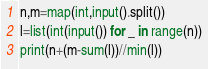<code> <loc_0><loc_0><loc_500><loc_500><_Python_>n,m=map(int,input().split())
l=list(int(input()) for _ in range(n))
print(n+(m-sum(l))//min(l))</code> 